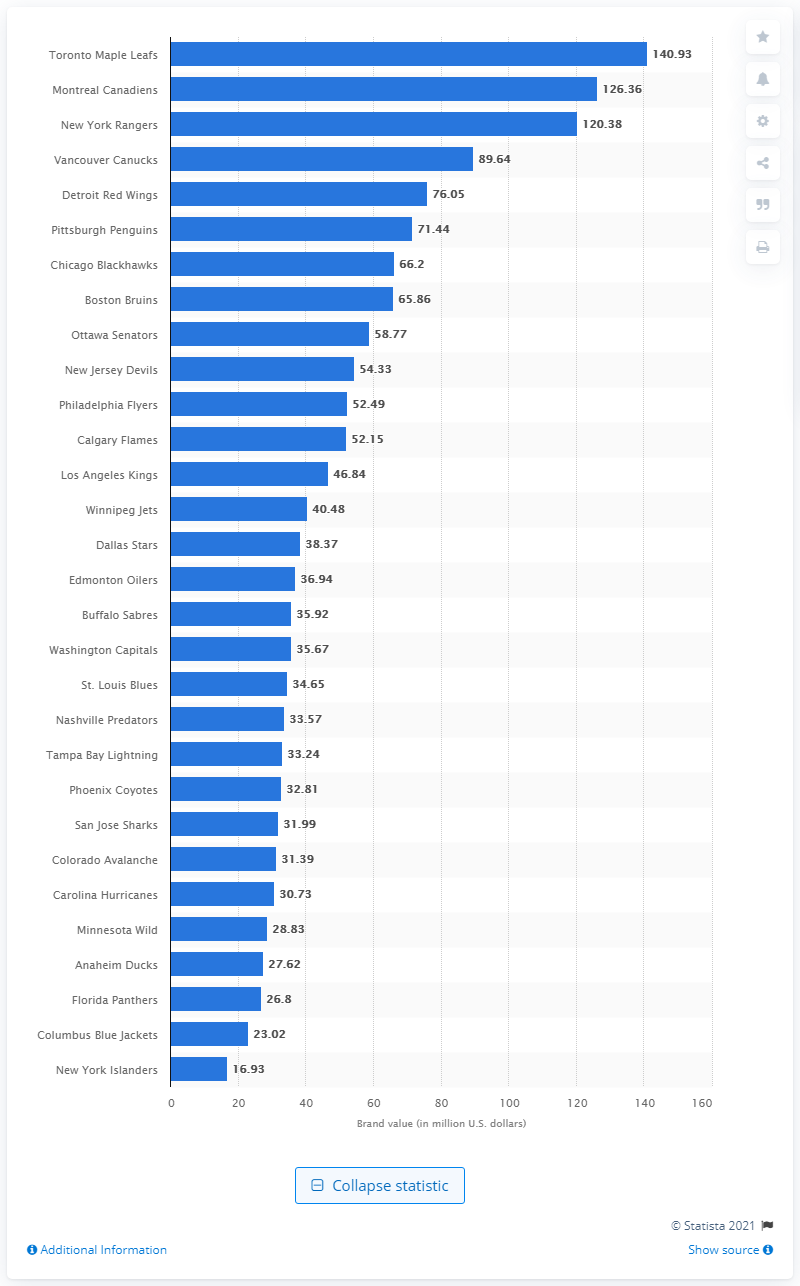Indicate a few pertinent items in this graphic. In 2013, the brand value of the Toronto Maple Leafs was 140.93. 